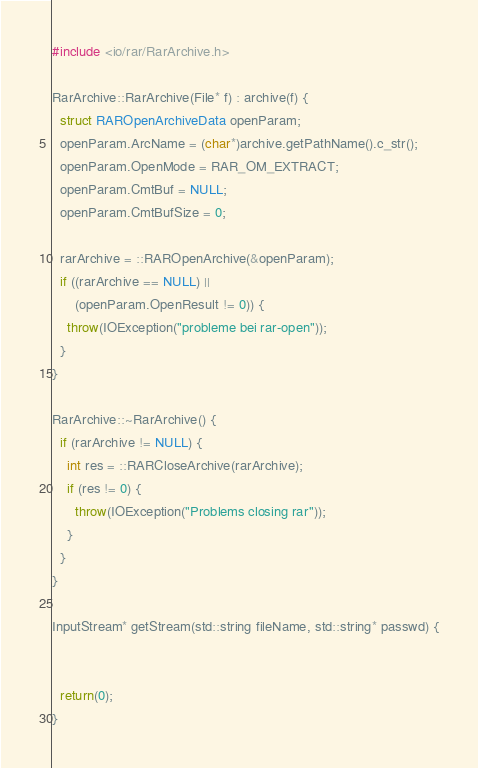Convert code to text. <code><loc_0><loc_0><loc_500><loc_500><_C++_>#include <io/rar/RarArchive.h>

RarArchive::RarArchive(File* f) : archive(f) {
  struct RAROpenArchiveData openParam;
  openParam.ArcName = (char*)archive.getPathName().c_str();
  openParam.OpenMode = RAR_OM_EXTRACT;
  openParam.CmtBuf = NULL;
  openParam.CmtBufSize = 0;

  rarArchive = ::RAROpenArchive(&openParam);
  if ((rarArchive == NULL) ||
      (openParam.OpenResult != 0)) {
    throw(IOException("probleme bei rar-open"));
  }
}

RarArchive::~RarArchive() {
  if (rarArchive != NULL) {
    int res = ::RARCloseArchive(rarArchive);
    if (res != 0) {
      throw(IOException("Problems closing rar"));
    }
  }
}

InputStream* getStream(std::string fileName, std::string* passwd) {

  
  return(0);
}
</code> 